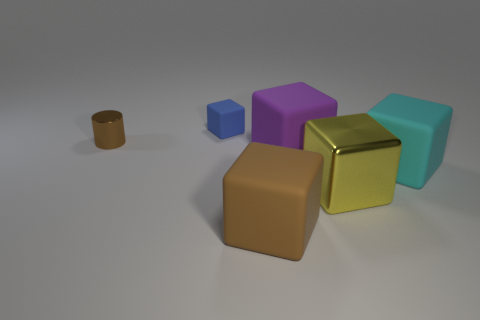What materials do the objects in the image appear to be made of? The objects seem to have various textures suggesting different materials. The brown cylinder looks like it could be made of a matte clay, the blue and purple cubes might be plastic given their slight shine, and the gold and aqua cubes could be metallic due to their reflective surfaces. 